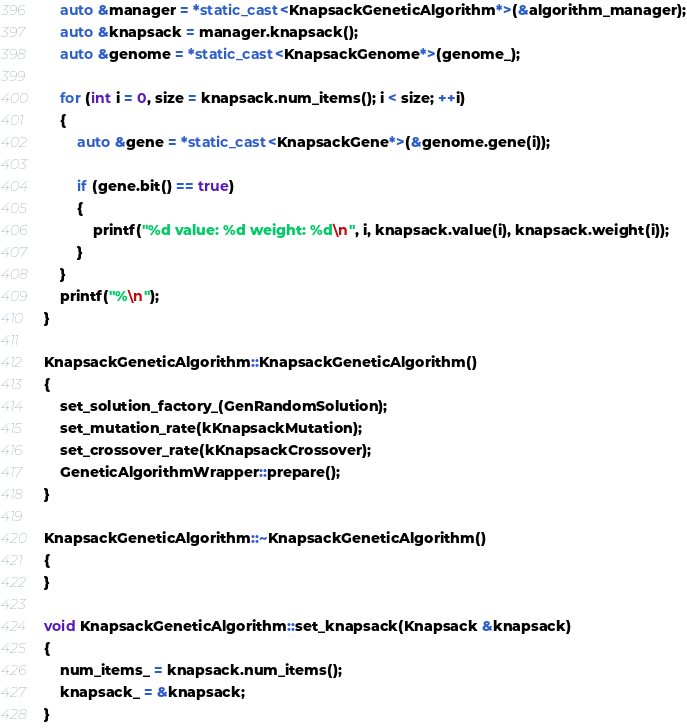Convert code to text. <code><loc_0><loc_0><loc_500><loc_500><_C++_>    auto &manager = *static_cast<KnapsackGeneticAlgorithm*>(&algorithm_manager);
    auto &knapsack = manager.knapsack();
    auto &genome = *static_cast<KnapsackGenome*>(genome_);

    for (int i = 0, size = knapsack.num_items(); i < size; ++i)
    {
        auto &gene = *static_cast<KnapsackGene*>(&genome.gene(i));

        if (gene.bit() == true)
        {
            printf("%d value: %d weight: %d\n", i, knapsack.value(i), knapsack.weight(i));
        }
    }
    printf("%\n");
}

KnapsackGeneticAlgorithm::KnapsackGeneticAlgorithm()
{
    set_solution_factory_(GenRandomSolution);
    set_mutation_rate(kKnapsackMutation);
    set_crossover_rate(kKnapsackCrossover);
    GeneticAlgorithmWrapper::prepare();
}

KnapsackGeneticAlgorithm::~KnapsackGeneticAlgorithm()
{
}

void KnapsackGeneticAlgorithm::set_knapsack(Knapsack &knapsack)
{
    num_items_ = knapsack.num_items();
    knapsack_ = &knapsack;
}</code> 